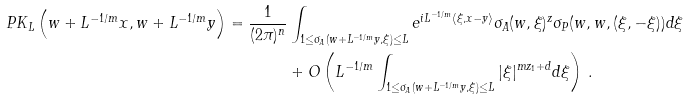<formula> <loc_0><loc_0><loc_500><loc_500>P K _ { L } \left ( w + L ^ { - 1 / m } x , w + L ^ { - 1 / m } y \right ) = \frac { 1 } { ( 2 \pi ) ^ { n } } & \int _ { 1 \leq \sigma _ { A } ( w + L ^ { - 1 / m } y , \xi ) \leq L } e ^ { i L ^ { - 1 / m } \langle \xi , x - y \rangle } \sigma _ { A } ( w , \xi ) ^ { z } \sigma _ { P } ( w , w , ( \xi , - \xi ) ) d \xi \\ & + O \left ( L ^ { - 1 / m } \int _ { 1 \leq \sigma _ { A } ( w + L ^ { - 1 / m } y , \xi ) \leq L } | \xi | ^ { m z _ { 1 } + d } d \xi \right ) \, .</formula> 